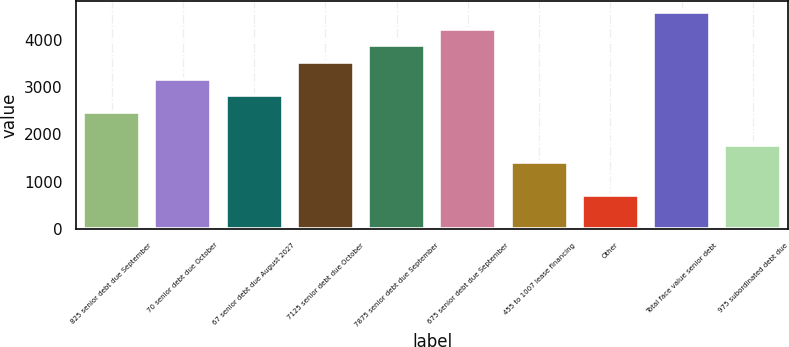<chart> <loc_0><loc_0><loc_500><loc_500><bar_chart><fcel>825 senior debt due September<fcel>70 senior debt due October<fcel>67 senior debt due August 2027<fcel>7125 senior debt due October<fcel>7875 senior debt due September<fcel>675 senior debt due September<fcel>455 to 1007 lease financing<fcel>Other<fcel>Total face value senior debt<fcel>975 subordinated debt due<nl><fcel>2472.3<fcel>3178.5<fcel>2825.4<fcel>3531.6<fcel>3884.7<fcel>4237.8<fcel>1413<fcel>706.8<fcel>4590.9<fcel>1766.1<nl></chart> 